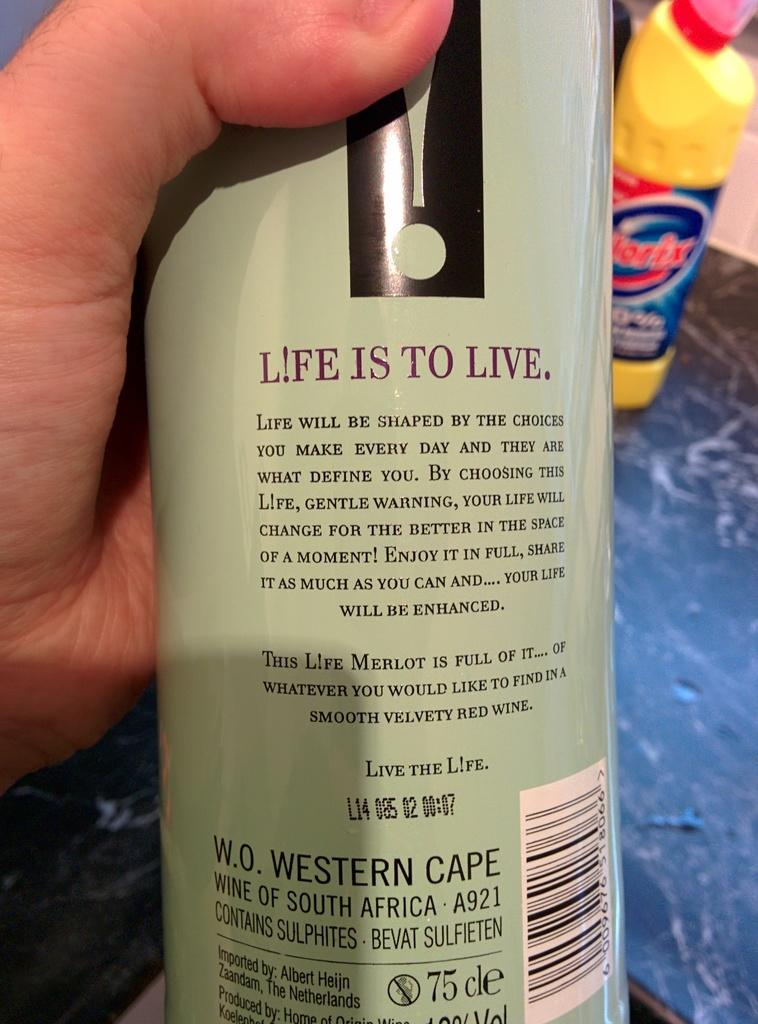Who or what is present in the image? There is a person in the image. What is the person holding? The person is holding a bottle. Are there any other bottles visible in the image? Yes, there is another bottle visible in the background of the image. Where is the second bottle located? The bottle in the background is on the floor. What type of bomb is the person holding in the image? There is no bomb present in the image; the person is holding a bottle. Can you see a fireman in the image? There is no fireman present in the image. 